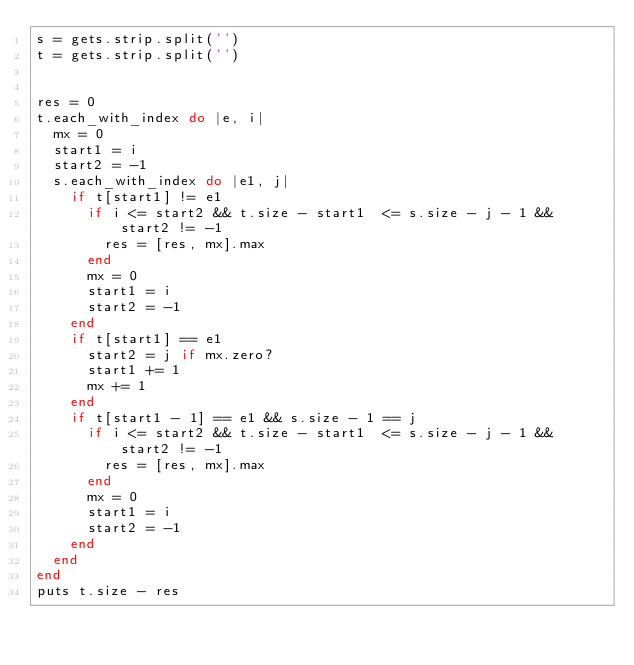<code> <loc_0><loc_0><loc_500><loc_500><_Ruby_>s = gets.strip.split('')
t = gets.strip.split('')


res = 0
t.each_with_index do |e, i|
  mx = 0
  start1 = i
  start2 = -1
  s.each_with_index do |e1, j|
    if t[start1] != e1
      if i <= start2 && t.size - start1  <= s.size - j - 1 && start2 != -1
        res = [res, mx].max
      end
      mx = 0
      start1 = i
      start2 = -1
    end
    if t[start1] == e1
      start2 = j if mx.zero?
      start1 += 1
      mx += 1
    end
    if t[start1 - 1] == e1 && s.size - 1 == j
      if i <= start2 && t.size - start1  <= s.size - j - 1 && start2 != -1
        res = [res, mx].max
      end
      mx = 0
      start1 = i
      start2 = -1
    end
  end
end
puts t.size - res</code> 